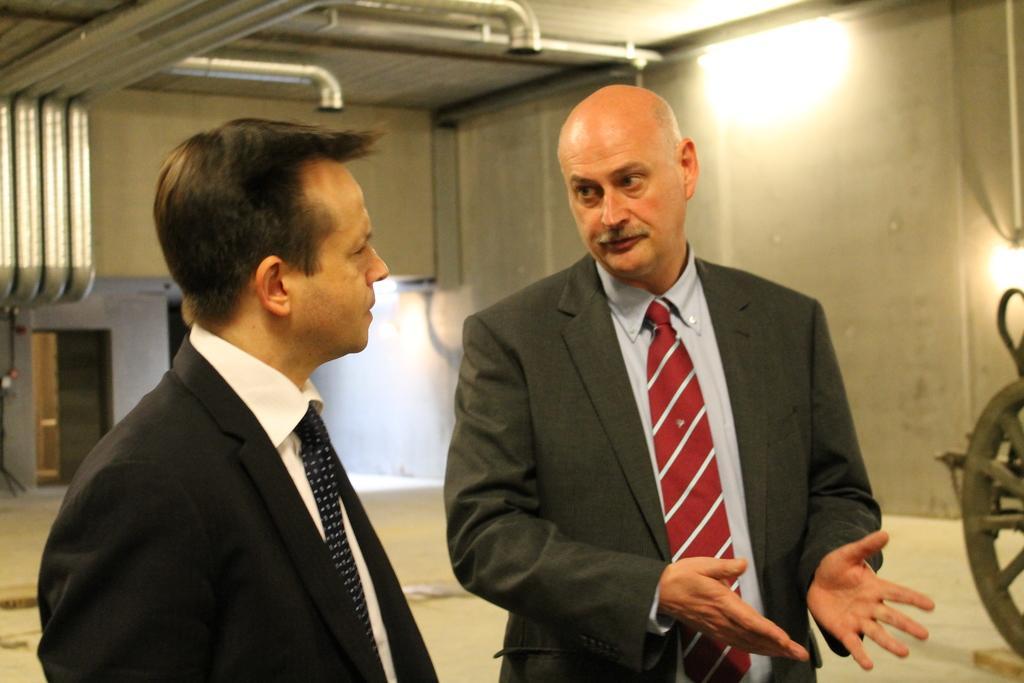In one or two sentences, can you explain what this image depicts? In this image there are two people standing, in the background there is a wall and there are lights, at the top there are pipes. 